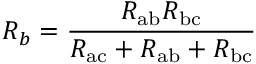Convert formula to latex. <formula><loc_0><loc_0><loc_500><loc_500>R _ { b } = { \frac { R _ { a b } R _ { b c } } { R _ { a c } + R _ { a b } + R _ { b c } } }</formula> 